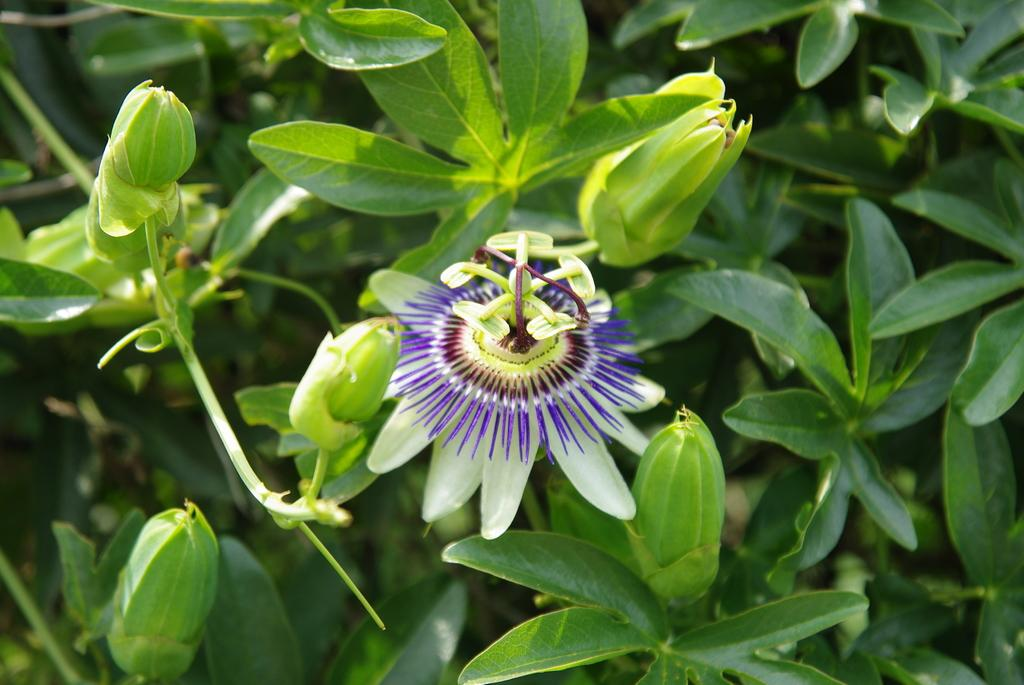What celestial bodies are depicted in the image? There are planets in the image. What type of plant is shown in the image? There is a flower in the image. What stage of growth are some of the plants in the image? There are buds in the image. What other parts of the plant can be seen in the image? There are leaves in the image. What color are the buds and leaves in the image? The buds and leaves are green in color. Where is the hill located in the image? There is no hill present in the image. How many oranges are hanging from the branches of the flower in the image? There are no oranges present in the image; it features a flower with buds and leaves. 